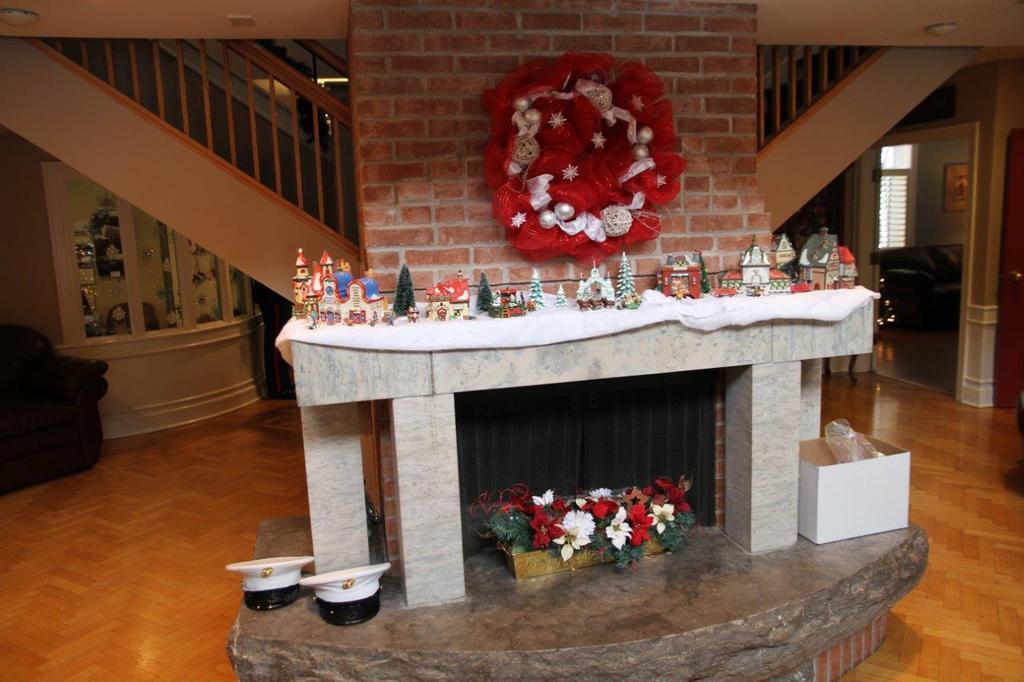How would you summarize this image in a sentence or two? In this image we can see a chimney area of a house. Beside the area one white color box, flower pots and two hats are there. On the wall one red color thing is attached , in front of it so many toys are present. Right side of the image one room is there, in room one sofa is present. Left side of the image one sofa is there. The floor is furnished with wood. 